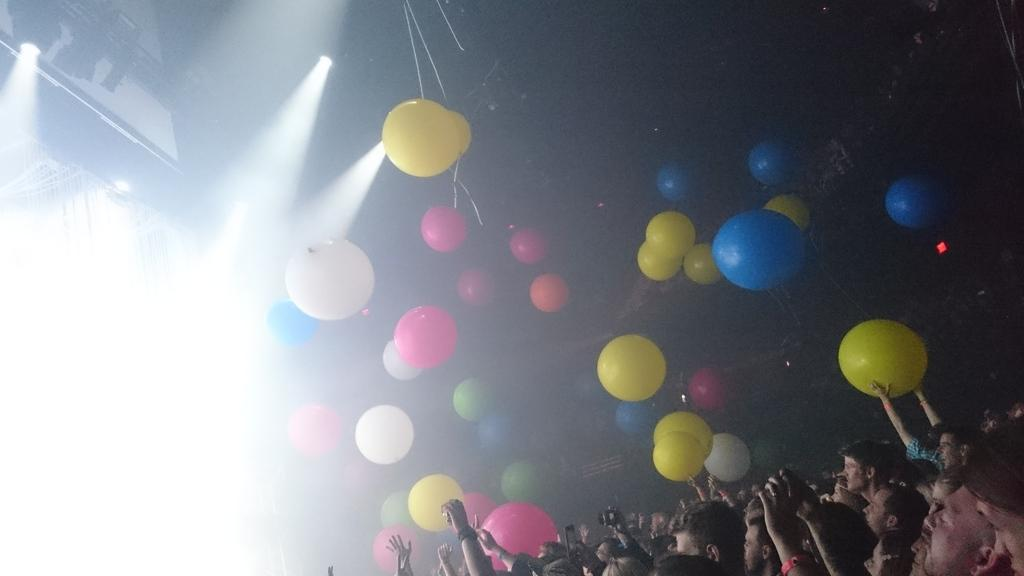Who or what is located at the bottom of the image? There are people at the bottom of the image. What can be seen in the middle of the image? There are balloons in the middle of the image. Where are the lights located in the image? The lights are on the left side of the image. What rate is the joke being told at in the image? There is no joke being told in the image, so there is no rate at which it is being told. Can you describe the curtain in the image? There is no curtain present in the image. 